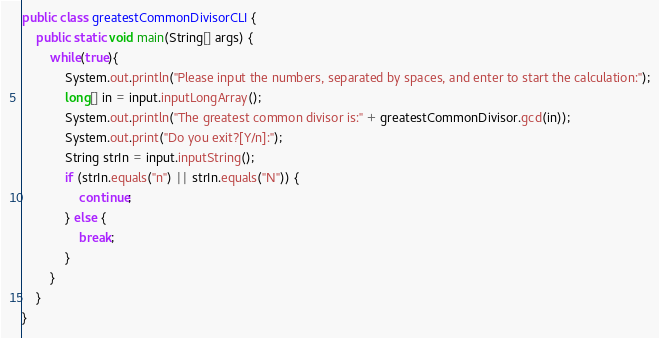Convert code to text. <code><loc_0><loc_0><loc_500><loc_500><_Java_>public class greatestCommonDivisorCLI {
    public static void main(String[] args) {
        while(true){
            System.out.println("Please input the numbers, separated by spaces, and enter to start the calculation:");
            long[] in = input.inputLongArray();
            System.out.println("The greatest common divisor is:" + greatestCommonDivisor.gcd(in));
            System.out.print("Do you exit?[Y/n]:");
            String strIn = input.inputString();
            if (strIn.equals("n") || strIn.equals("N")) {
                continue;
            } else {
                break;
            }
        }
    }
}</code> 